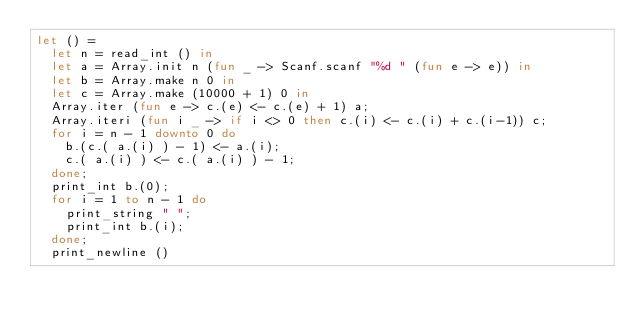Convert code to text. <code><loc_0><loc_0><loc_500><loc_500><_OCaml_>let () =
  let n = read_int () in
  let a = Array.init n (fun _ -> Scanf.scanf "%d " (fun e -> e)) in
  let b = Array.make n 0 in
  let c = Array.make (10000 + 1) 0 in
  Array.iter (fun e -> c.(e) <- c.(e) + 1) a;
  Array.iteri (fun i _ -> if i <> 0 then c.(i) <- c.(i) + c.(i-1)) c;
  for i = n - 1 downto 0 do
    b.(c.( a.(i) ) - 1) <- a.(i);
    c.( a.(i) ) <- c.( a.(i) ) - 1;
  done;
  print_int b.(0);
  for i = 1 to n - 1 do
    print_string " ";
    print_int b.(i);
  done;
  print_newline ()</code> 